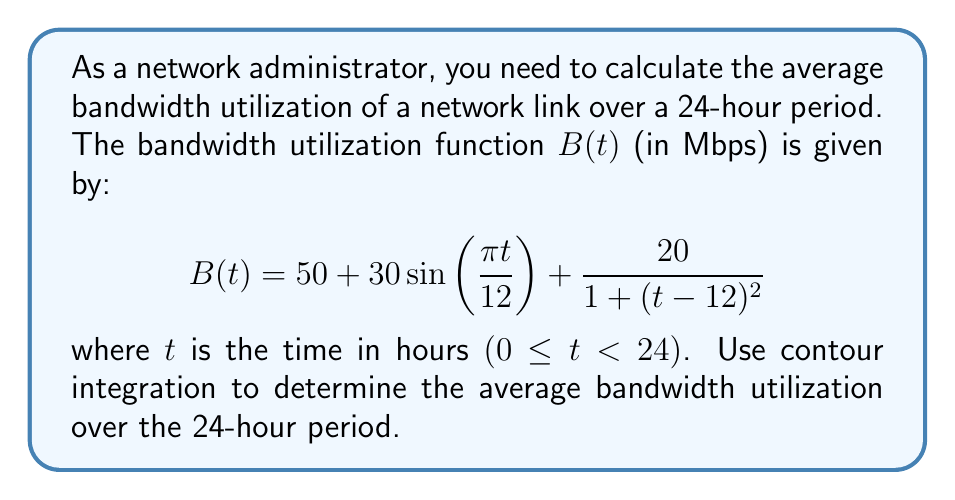Provide a solution to this math problem. To solve this problem, we'll use the following steps:

1) The average bandwidth utilization is given by:

   $$\text{Average} = \frac{1}{24}\int_0^{24} B(t) dt$$

2) We can extend this to a complex contour integral. Let $z = e^{i\pi t/12}$. Then $t = -\frac{12i}{\pi}\ln z$ and $dt = -\frac{12i}{\pi}\frac{dz}{z}$.

3) The contour will be the unit circle in the complex plane, traversed counterclockwise once.

4) We need to express $B(t)$ in terms of $z$:

   $$B(z) = 50 + 30\frac{z-z^{-1}}{2i} + \frac{20}{1 + (12i\ln z/\pi)^2}$$

5) The integral becomes:

   $$\text{Average} = \frac{1}{24}\oint_C B(z) \cdot \left(-\frac{12i}{\pi}\frac{dz}{z}\right)$$

6) Simplify:

   $$\text{Average} = -\frac{i}{2\pi}\oint_C \left(50 + 30\frac{z-z^{-1}}{2i} + \frac{20}{1 + (12i\ln z/\pi)^2}\right)\frac{dz}{z}$$

7) The first term contributes $50$ to the average (residue theorem).

8) The second term has residues at $z=0$ and $z=\infty$, which cancel out.

9) The third term is holomorphic inside the unit circle, so it contributes nothing.

Therefore, the average bandwidth utilization is 50 Mbps.
Answer: The average bandwidth utilization over the 24-hour period is 50 Mbps. 